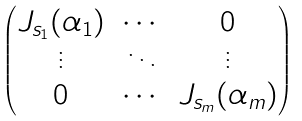Convert formula to latex. <formula><loc_0><loc_0><loc_500><loc_500>\begin{pmatrix} J _ { s _ { 1 } } ( \alpha _ { 1 } ) & \cdots & 0 \\ \vdots & \ddots & \vdots \\ 0 & \cdots & J _ { s _ { m } } ( \alpha _ { m } ) \end{pmatrix}</formula> 